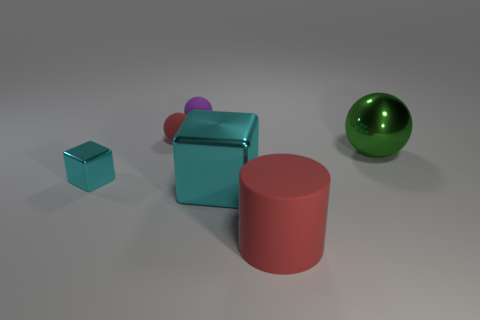Subtract all tiny matte balls. How many balls are left? 1 Add 4 large things. How many objects exist? 10 Subtract all green spheres. How many spheres are left? 2 Subtract 1 cylinders. How many cylinders are left? 0 Subtract all blocks. How many objects are left? 4 Subtract all red cubes. Subtract all red spheres. How many cubes are left? 2 Subtract all green cylinders. How many green spheres are left? 1 Subtract all large red objects. Subtract all tiny objects. How many objects are left? 2 Add 4 cyan shiny blocks. How many cyan shiny blocks are left? 6 Add 2 green objects. How many green objects exist? 3 